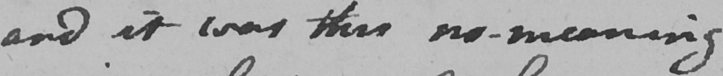What text is written in this handwritten line? and it was this no-meaning 